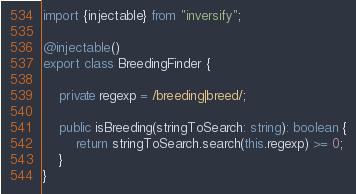Convert code to text. <code><loc_0><loc_0><loc_500><loc_500><_TypeScript_>import {injectable} from "inversify";

@injectable()
export class BreedingFinder {

    private regexp = /breeding|breed/;

    public isBreeding(stringToSearch: string): boolean {
        return stringToSearch.search(this.regexp) >= 0;
    }
}</code> 